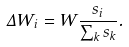<formula> <loc_0><loc_0><loc_500><loc_500>\Delta W _ { i } = W \frac { s _ { i } } { \sum _ { k } s _ { k } } .</formula> 